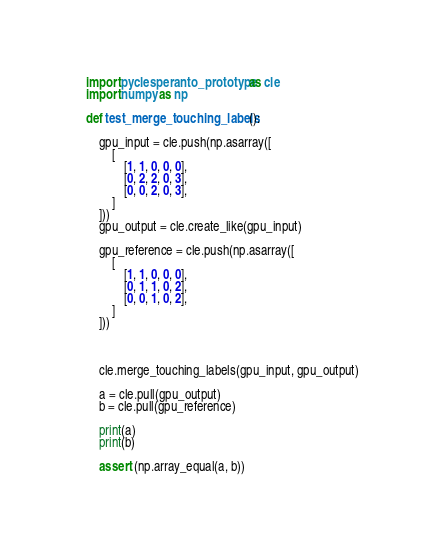Convert code to text. <code><loc_0><loc_0><loc_500><loc_500><_Python_>import pyclesperanto_prototype as cle
import numpy as np

def test_merge_touching_labels():

    gpu_input = cle.push(np.asarray([
        [
            [1, 1, 0, 0, 0],
            [0, 2, 2, 0, 3],
            [0, 0, 2, 0, 3],
        ]
    ]))
    gpu_output = cle.create_like(gpu_input)

    gpu_reference = cle.push(np.asarray([
        [
            [1, 1, 0, 0, 0],
            [0, 1, 1, 0, 2],
            [0, 0, 1, 0, 2],
        ]
    ]))



    cle.merge_touching_labels(gpu_input, gpu_output)

    a = cle.pull(gpu_output)
    b = cle.pull(gpu_reference)

    print(a)
    print(b)

    assert (np.array_equal(a, b))</code> 